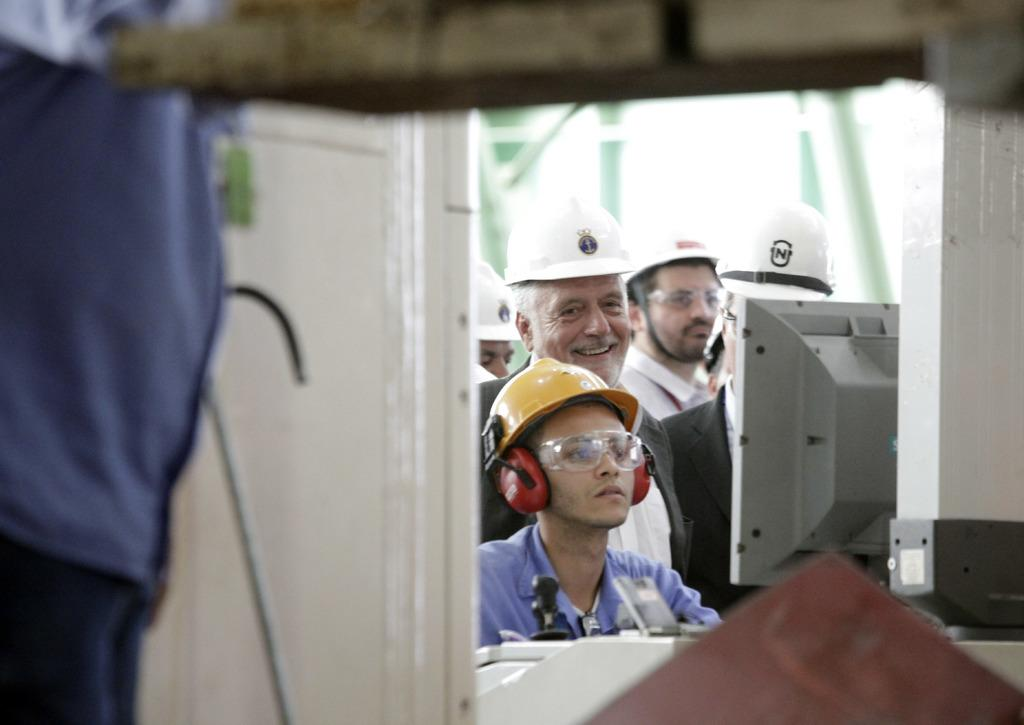How many people are in the image? There are people in the image, but the exact number is not specified. What type of device can be seen in the image? There is a device in the image, but its specific function or type is not mentioned. What kind of objects are present in the image? There are objects in the image, but their nature or purpose is not described. Where is the door located in the image? There is a door in the image, but its position or orientation is not specified. What is the color of the black colored object in the image? There is a black colored object in the image, but its shape or function is not mentioned. What is located at the bottom of the image? There is an object at the bottom of the image, but its nature or purpose is not described. What type of motion can be seen in the image? There is no specific motion depicted in the image. Which direction is north in the image? The image does not provide any information about the direction of north. 